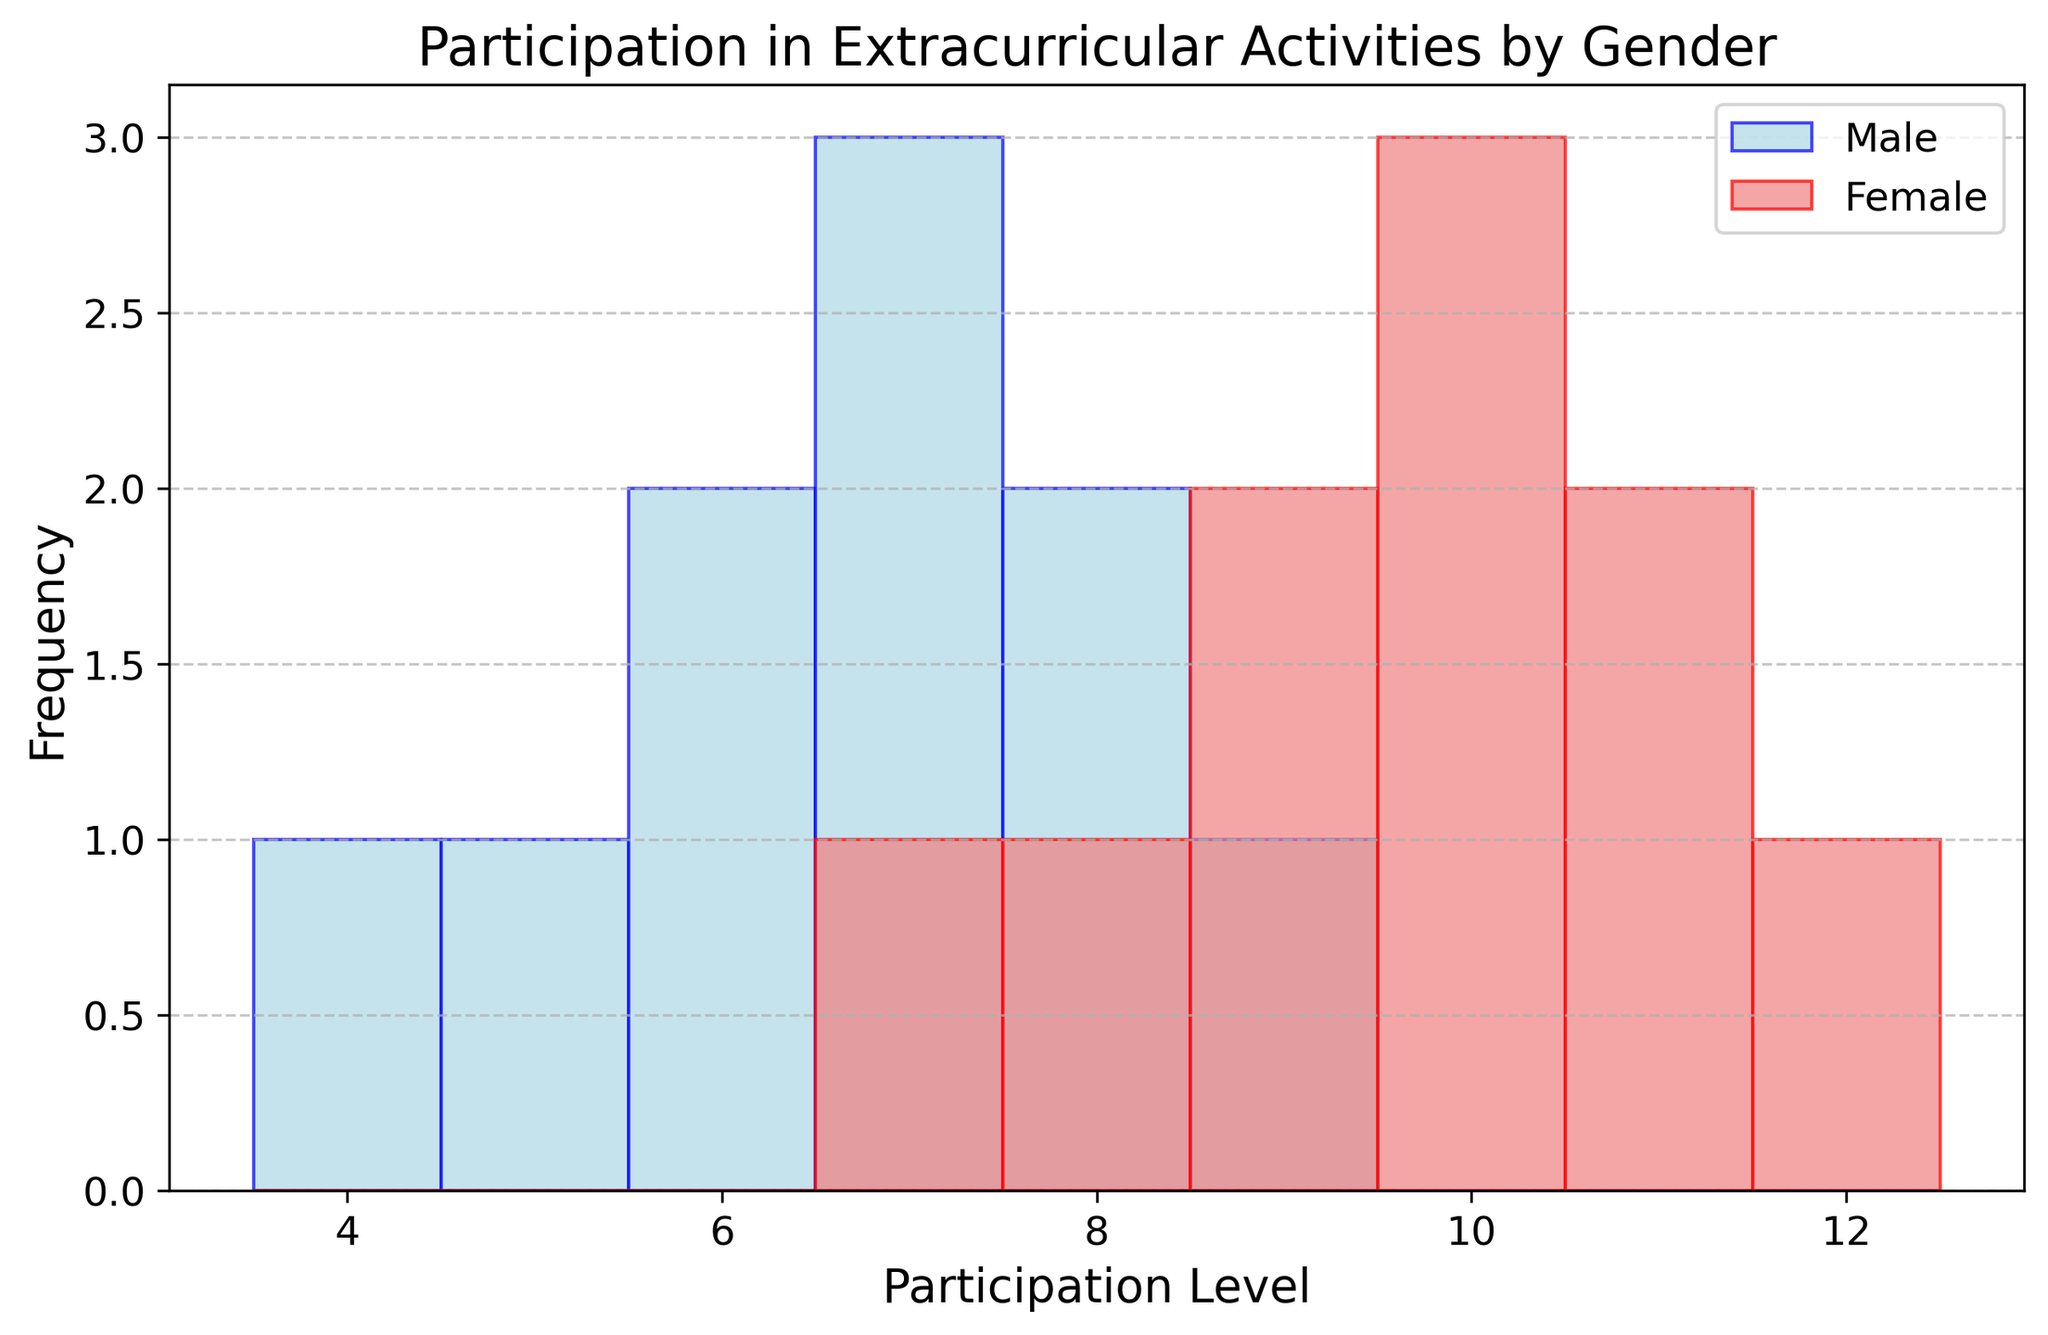Which gender has a higher frequency of participation at the level 10? By looking at the histogram, count the number of bars corresponding to the participation level 10 for both genders. Female has 3 bars, whereas Male has 0.
Answer: Female How many males participated at the level 7? Count the number of bars at the participation level 7 for males. There are 3 bars corresponding to this level for males.
Answer: 3 What is the total participation frequency for females? Count all the bars representing female participants across all levels: 1 (at 7) + 1 (at 8) + 1 (at 9) + 3 (at 10) + 2 (at 11) + 1 (at 12) = 9 bars.
Answer: 9 Which level has the highest participation for females? Check the histogram and find the highest bar for females. The highest bar for females occurs at levels 10 and 11, with a woman count of 3 each.
Answer: 10 or 11 How does the participation of males at level 7 compare to females at the same level? Compare the height of the bars for males and females at level 7. There are 3 males and 1 female. Explanation: Count the height of the bars for male/female at level 7 and compare. There are 3 males and 1 female at this level.
Answer: Males have higher participation at level 7 What is the average participation level for males? Calculate the sum of the participation levels for males (7 + 5 + 8 + 6 + 7 + 9 + 4 + 8 + 7 + 6 = 67) and divide by the number of males (10). The average is 67/10 = 6.7
Answer: 6.7 At which participation level is there an equal frequency for males and females? Compare the height of the bars for both genders at each participation level. Only at level 9, both genders have the same frequency (1 bar each).
Answer: 9 Which gender has a higher overall frequency of participation above level 6? Consider the number of bars for each gender above level 6. Females have 9 bars, while males have 6 bars: Female's count (10, 12, 7, 11, 9, 10, 8, 9, 10, 11) = 10, Male's count (7, 5, 8, 6, 7, 9, 4, 8, 7, 6) = 6.
Answer: Female What is the difference in the highest participation level between genders? Identify the highest participation level for each gender and calculate the difference. Females' highest is 12, and males' highest is 9, so the difference is 12 - 9 = 3.
Answer: 3 What is the median participation level for males? To find the median, sort the male participation levels (4, 5, 6, 6, 7, 7, 7, 8, 8, 9) and identify the middle value. Since there are 10 values, the median is the average of the 5th and 6th values: (7+7)/2 = 7.
Answer: 7 